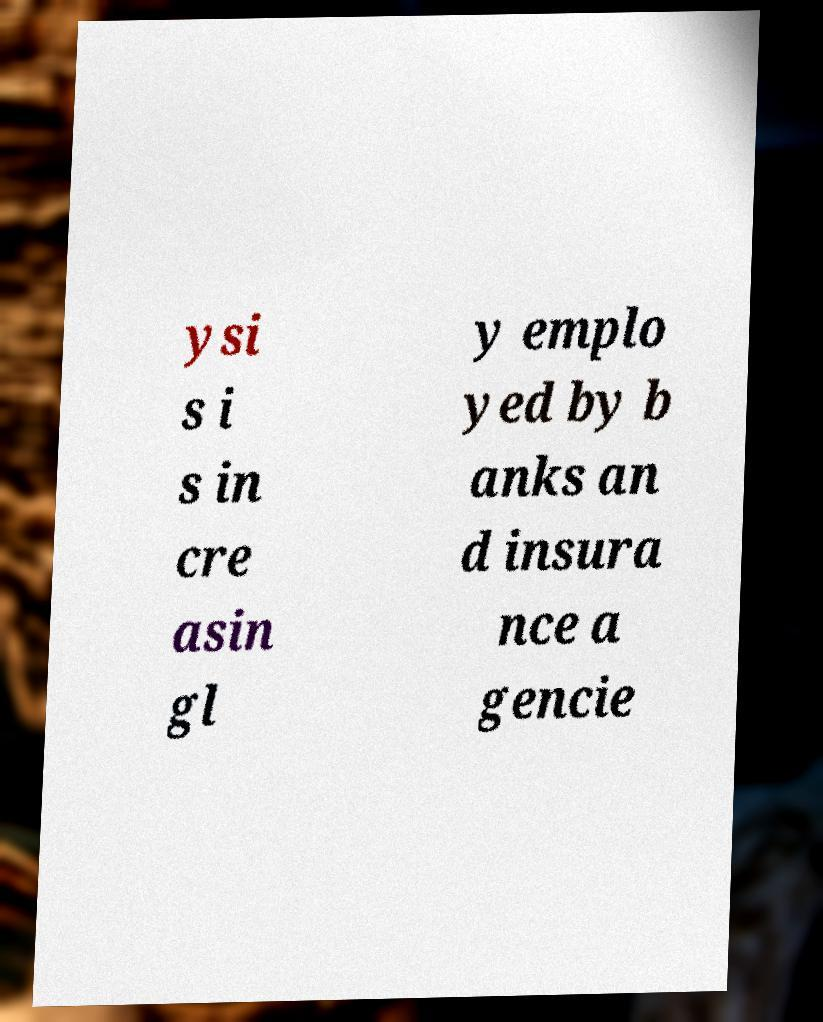There's text embedded in this image that I need extracted. Can you transcribe it verbatim? ysi s i s in cre asin gl y emplo yed by b anks an d insura nce a gencie 